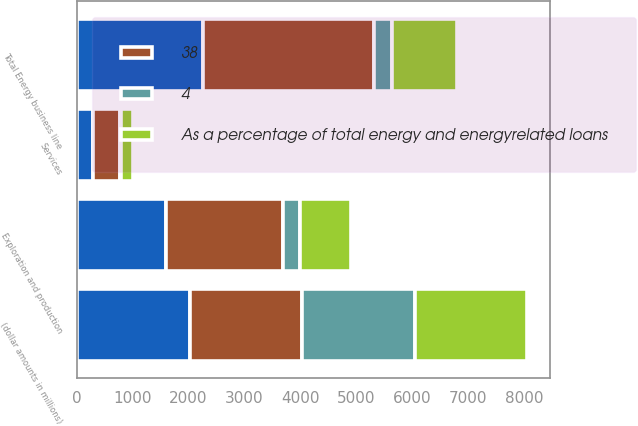<chart> <loc_0><loc_0><loc_500><loc_500><stacked_bar_chart><ecel><fcel>(dollar amounts in millions)<fcel>Exploration and production<fcel>Services<fcel>Total Energy business line<nl><fcel>nan<fcel>2016<fcel>1587<fcel>289<fcel>2250<nl><fcel>4<fcel>2016<fcel>294<fcel>27<fcel>328<nl><fcel>As a percentage of total energy and energyrelated loans<fcel>2016<fcel>910<fcel>200<fcel>1155<nl><fcel>38<fcel>2015<fcel>2111<fcel>480<fcel>3070<nl></chart> 